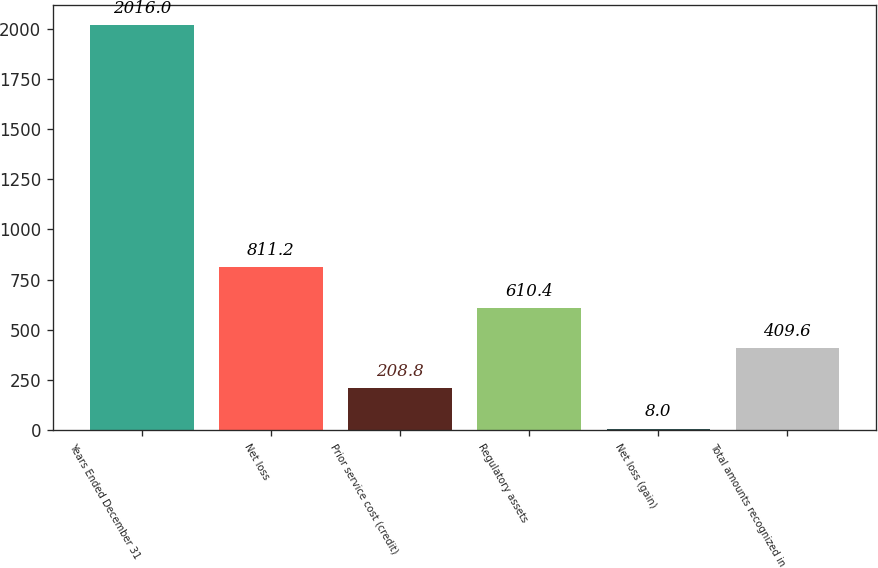Convert chart. <chart><loc_0><loc_0><loc_500><loc_500><bar_chart><fcel>Years Ended December 31<fcel>Net loss<fcel>Prior service cost (credit)<fcel>Regulatory assets<fcel>Net loss (gain)<fcel>Total amounts recognized in<nl><fcel>2016<fcel>811.2<fcel>208.8<fcel>610.4<fcel>8<fcel>409.6<nl></chart> 